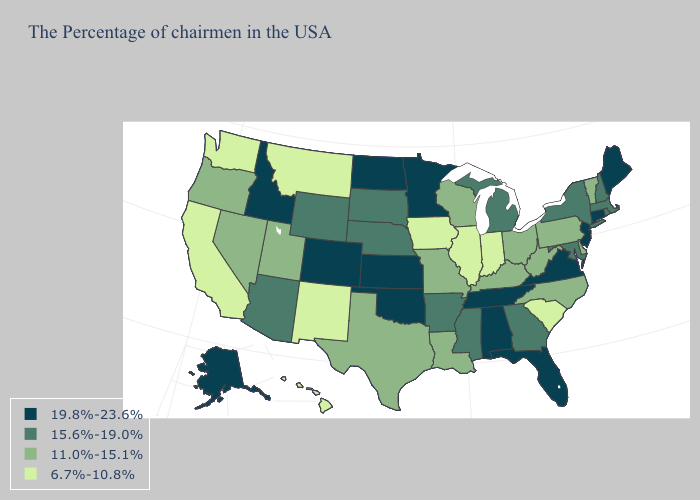Among the states that border Kentucky , does Tennessee have the highest value?
Be succinct. Yes. Name the states that have a value in the range 6.7%-10.8%?
Short answer required. South Carolina, Indiana, Illinois, Iowa, New Mexico, Montana, California, Washington, Hawaii. What is the highest value in states that border Alabama?
Write a very short answer. 19.8%-23.6%. What is the value of Wisconsin?
Be succinct. 11.0%-15.1%. What is the value of Michigan?
Answer briefly. 15.6%-19.0%. Among the states that border Maryland , which have the highest value?
Write a very short answer. Virginia. What is the value of Illinois?
Answer briefly. 6.7%-10.8%. What is the lowest value in states that border Minnesota?
Give a very brief answer. 6.7%-10.8%. Among the states that border Rhode Island , does Massachusetts have the lowest value?
Be succinct. Yes. What is the value of Wisconsin?
Quick response, please. 11.0%-15.1%. What is the highest value in the USA?
Keep it brief. 19.8%-23.6%. Among the states that border Wisconsin , does Illinois have the lowest value?
Write a very short answer. Yes. Name the states that have a value in the range 11.0%-15.1%?
Give a very brief answer. Vermont, Delaware, Pennsylvania, North Carolina, West Virginia, Ohio, Kentucky, Wisconsin, Louisiana, Missouri, Texas, Utah, Nevada, Oregon. Among the states that border Oklahoma , does Kansas have the highest value?
Give a very brief answer. Yes. What is the value of New Jersey?
Be succinct. 19.8%-23.6%. 